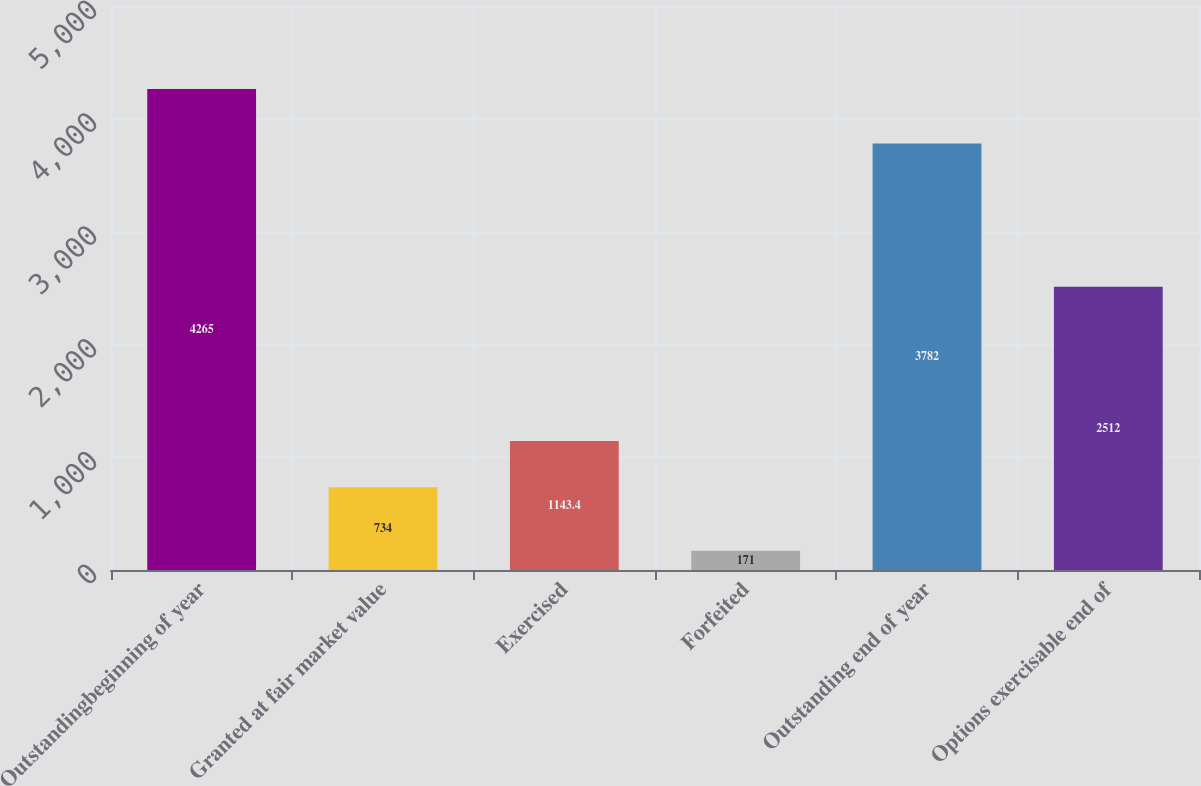Convert chart to OTSL. <chart><loc_0><loc_0><loc_500><loc_500><bar_chart><fcel>Outstandingbeginning of year<fcel>Granted at fair market value<fcel>Exercised<fcel>Forfeited<fcel>Outstanding end of year<fcel>Options exercisable end of<nl><fcel>4265<fcel>734<fcel>1143.4<fcel>171<fcel>3782<fcel>2512<nl></chart> 